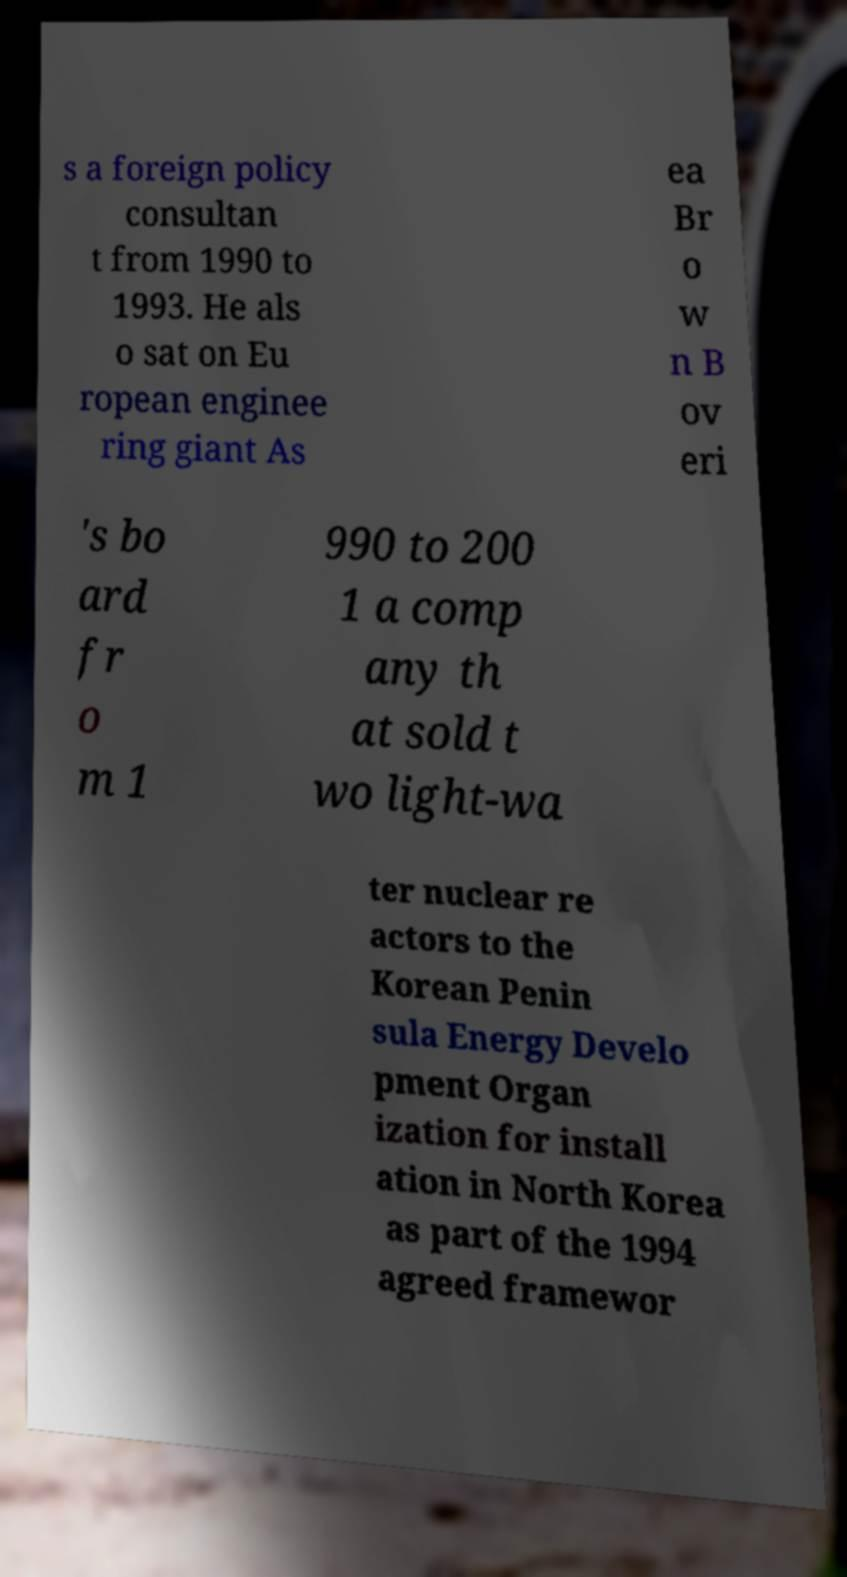There's text embedded in this image that I need extracted. Can you transcribe it verbatim? s a foreign policy consultan t from 1990 to 1993. He als o sat on Eu ropean enginee ring giant As ea Br o w n B ov eri 's bo ard fr o m 1 990 to 200 1 a comp any th at sold t wo light-wa ter nuclear re actors to the Korean Penin sula Energy Develo pment Organ ization for install ation in North Korea as part of the 1994 agreed framewor 